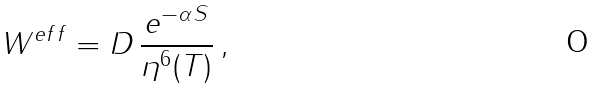<formula> <loc_0><loc_0><loc_500><loc_500>W ^ { e f f } = D \, \frac { e ^ { - \alpha S } } { \eta ^ { 6 } ( T ) } \, ,</formula> 